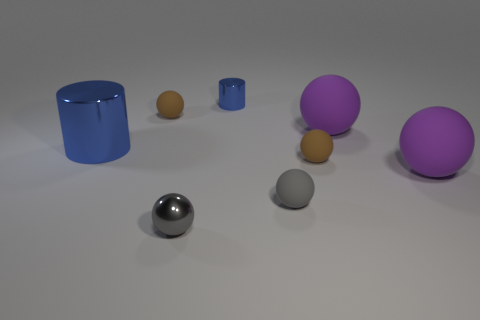Subtract all metallic spheres. How many spheres are left? 5 Add 1 small brown things. How many objects exist? 9 Subtract all purple spheres. How many spheres are left? 4 Subtract 1 spheres. How many spheres are left? 5 Subtract all red cubes. How many gray balls are left? 2 Subtract all shiny cylinders. Subtract all red metallic cylinders. How many objects are left? 6 Add 3 cylinders. How many cylinders are left? 5 Add 1 tiny rubber objects. How many tiny rubber objects exist? 4 Subtract 1 brown balls. How many objects are left? 7 Subtract all spheres. How many objects are left? 2 